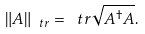<formula> <loc_0><loc_0><loc_500><loc_500>\| A \| _ { \ t r } = \ t r \sqrt { A ^ { \dagger } A } .</formula> 